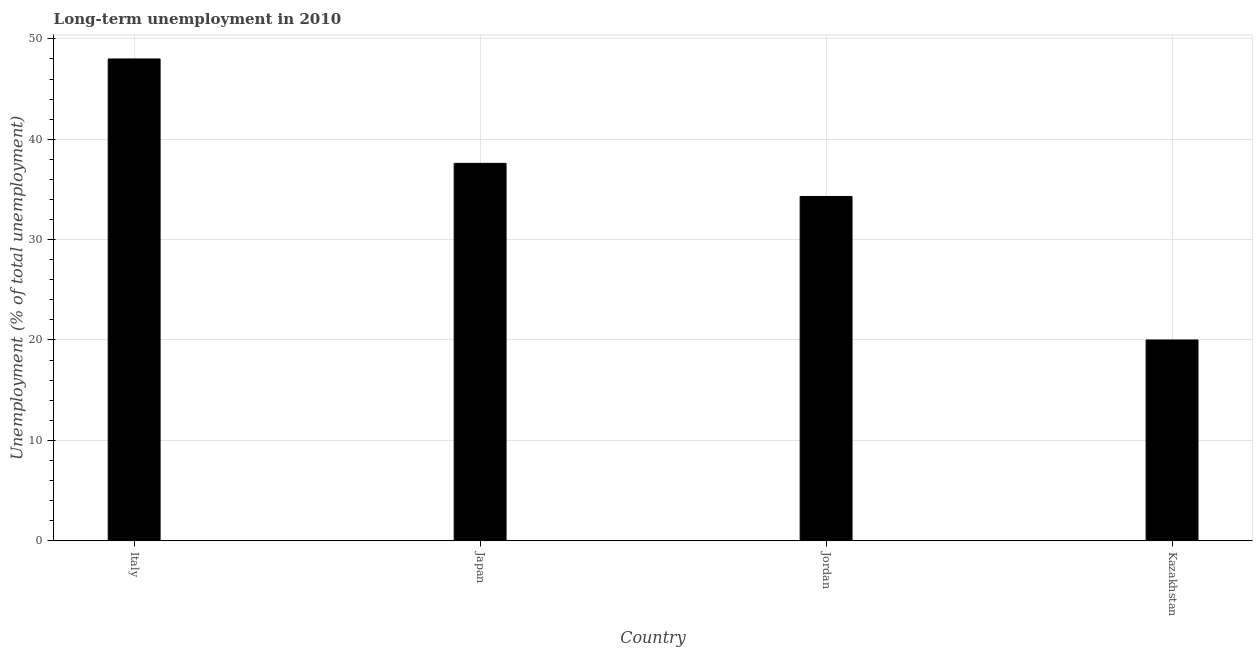Does the graph contain any zero values?
Your response must be concise. No. Does the graph contain grids?
Offer a terse response. Yes. What is the title of the graph?
Give a very brief answer. Long-term unemployment in 2010. What is the label or title of the Y-axis?
Make the answer very short. Unemployment (% of total unemployment). Across all countries, what is the minimum long-term unemployment?
Make the answer very short. 20. In which country was the long-term unemployment maximum?
Give a very brief answer. Italy. In which country was the long-term unemployment minimum?
Provide a succinct answer. Kazakhstan. What is the sum of the long-term unemployment?
Ensure brevity in your answer.  139.9. What is the average long-term unemployment per country?
Keep it short and to the point. 34.98. What is the median long-term unemployment?
Offer a very short reply. 35.95. What is the ratio of the long-term unemployment in Japan to that in Kazakhstan?
Your answer should be very brief. 1.88. Is the difference between the long-term unemployment in Italy and Jordan greater than the difference between any two countries?
Provide a short and direct response. No. What is the difference between the highest and the lowest long-term unemployment?
Give a very brief answer. 28. In how many countries, is the long-term unemployment greater than the average long-term unemployment taken over all countries?
Ensure brevity in your answer.  2. Are all the bars in the graph horizontal?
Your answer should be very brief. No. How many countries are there in the graph?
Give a very brief answer. 4. Are the values on the major ticks of Y-axis written in scientific E-notation?
Your answer should be very brief. No. What is the Unemployment (% of total unemployment) of Italy?
Offer a very short reply. 48. What is the Unemployment (% of total unemployment) of Japan?
Keep it short and to the point. 37.6. What is the Unemployment (% of total unemployment) in Jordan?
Provide a succinct answer. 34.3. What is the difference between the Unemployment (% of total unemployment) in Italy and Jordan?
Provide a succinct answer. 13.7. What is the difference between the Unemployment (% of total unemployment) in Italy and Kazakhstan?
Provide a short and direct response. 28. What is the difference between the Unemployment (% of total unemployment) in Japan and Kazakhstan?
Your answer should be very brief. 17.6. What is the ratio of the Unemployment (% of total unemployment) in Italy to that in Japan?
Provide a short and direct response. 1.28. What is the ratio of the Unemployment (% of total unemployment) in Italy to that in Jordan?
Keep it short and to the point. 1.4. What is the ratio of the Unemployment (% of total unemployment) in Japan to that in Jordan?
Keep it short and to the point. 1.1. What is the ratio of the Unemployment (% of total unemployment) in Japan to that in Kazakhstan?
Give a very brief answer. 1.88. What is the ratio of the Unemployment (% of total unemployment) in Jordan to that in Kazakhstan?
Provide a short and direct response. 1.72. 